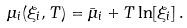Convert formula to latex. <formula><loc_0><loc_0><loc_500><loc_500>\mu _ { i } ( \xi _ { i } , T ) = \bar { \mu } _ { i } + T \ln [ \xi _ { i } ] \, .</formula> 